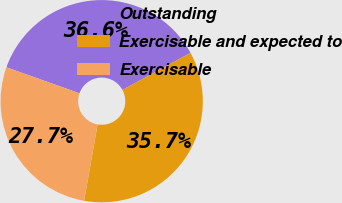Convert chart to OTSL. <chart><loc_0><loc_0><loc_500><loc_500><pie_chart><fcel>Outstanding<fcel>Exercisable and expected to<fcel>Exercisable<nl><fcel>36.63%<fcel>35.71%<fcel>27.66%<nl></chart> 